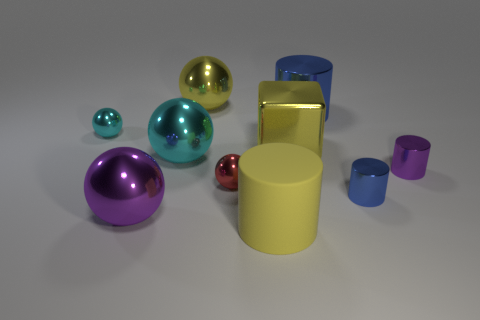Subtract all cyan cubes. How many cyan spheres are left? 2 Subtract all small red spheres. How many spheres are left? 4 Subtract all cyan balls. How many balls are left? 3 Subtract 2 balls. How many balls are left? 3 Subtract all blue spheres. Subtract all gray blocks. How many spheres are left? 5 Subtract all cubes. How many objects are left? 9 Subtract 1 purple cylinders. How many objects are left? 9 Subtract all yellow rubber things. Subtract all shiny balls. How many objects are left? 4 Add 4 yellow rubber cylinders. How many yellow rubber cylinders are left? 5 Add 3 big yellow rubber cylinders. How many big yellow rubber cylinders exist? 4 